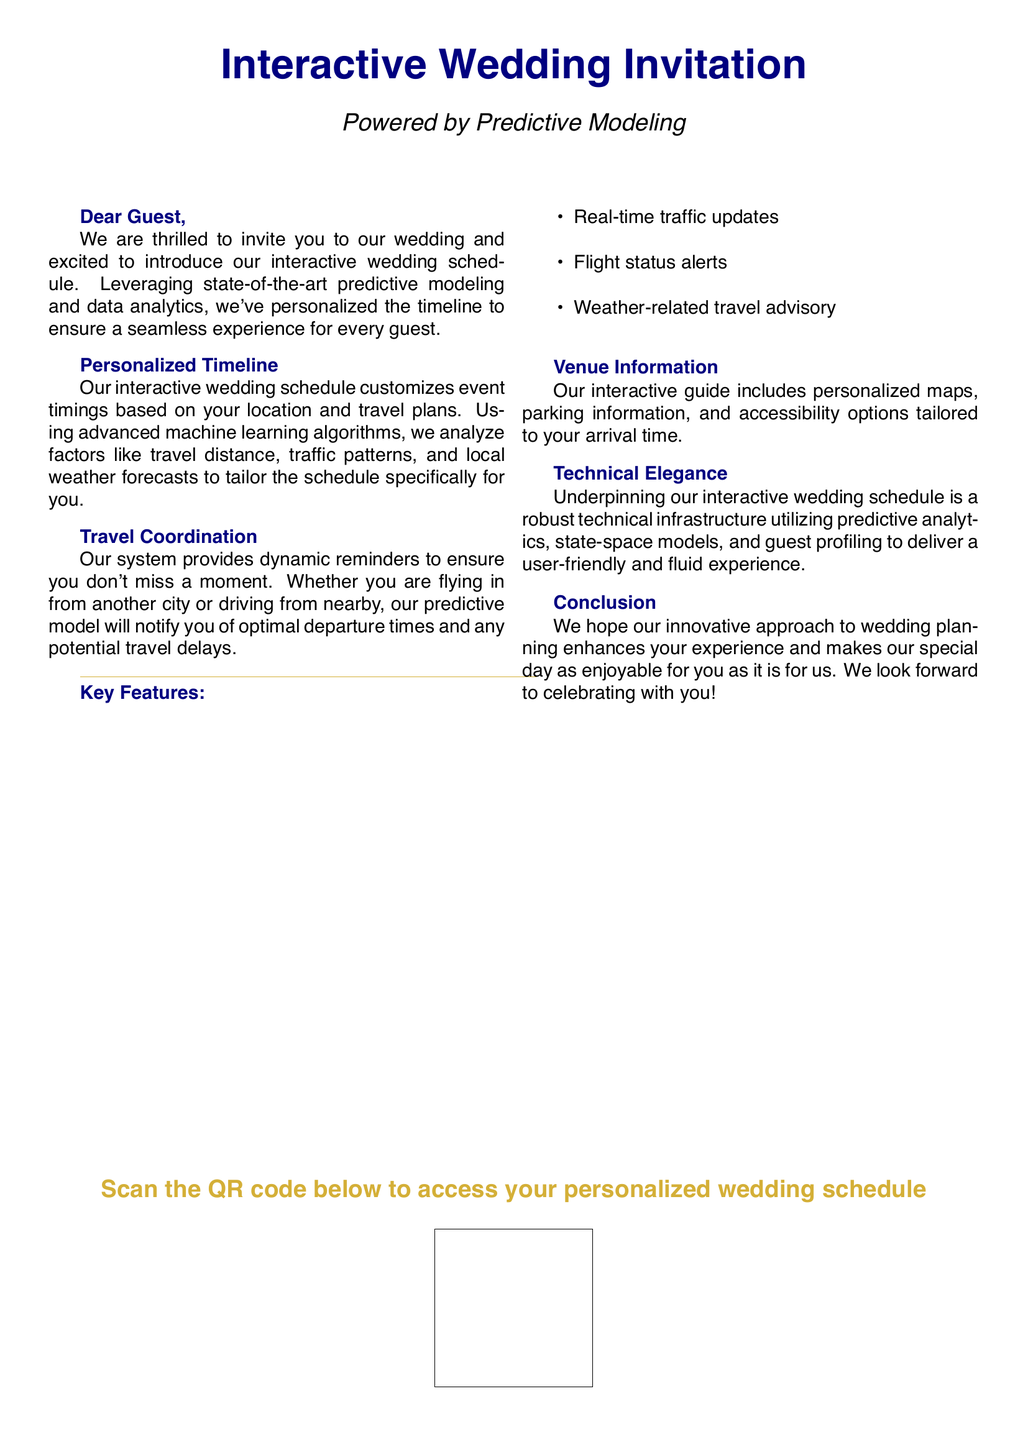What is the title of the document? The title is clearly stated in the center of the document.
Answer: Interactive Wedding Invitation What is the font used in the document? The document specifies the main font used throughout.
Answer: Helvetica What is the color used for the horizontal rule? The document indicates the color used for the rule separating sections.
Answer: Gold What technology powers the interactive wedding schedule? The text mentions the method that enhances the schedule's functionality.
Answer: Predictive Modeling What are the three key features listed in the document? The document provides a list of features focusing on guest experience.
Answer: Real-time traffic updates, Flight status alerts, Weather-related travel advisory What does the document ask guests to scan? The document concludes with an action item for guests concerning a QR code.
Answer: QR code How personalized is the schedule according to the document? The document emphasizes the schedule's customization based on multiple factors.
Answer: Tailored to your location and travel plans What type of information does the venue guide include? The document specifies the type of information available in the guide.
Answer: Personalized maps, parking information, and accessibility options What does the conclusion of the document express? The conclusion states the document's aim regarding the guests' experience on the wedding day.
Answer: Enhances your experience 